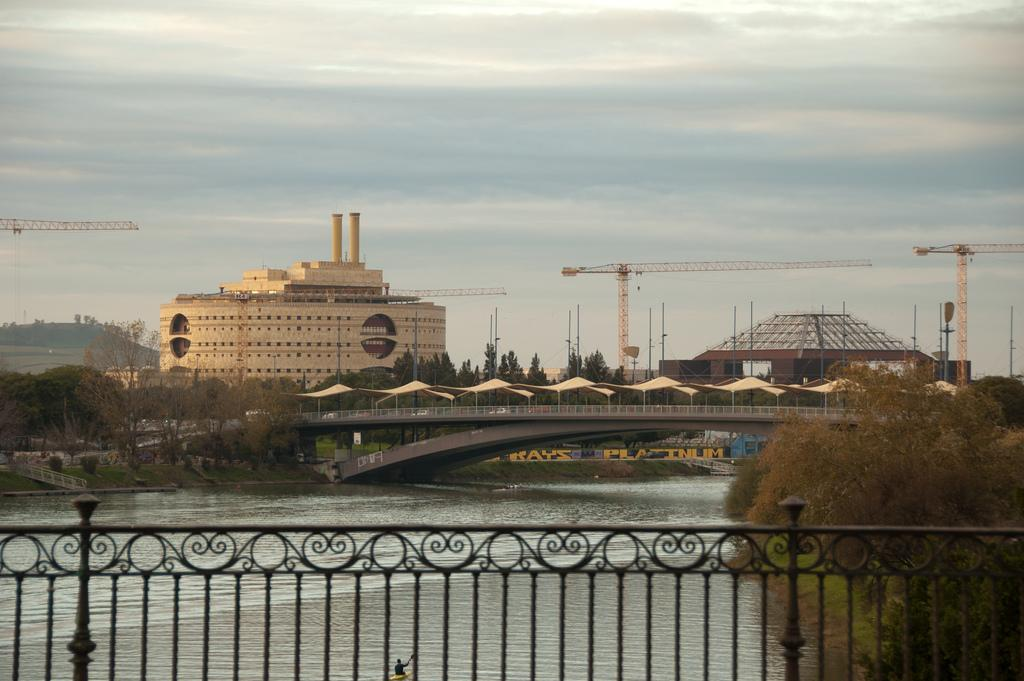What type of structure can be seen in the image? There is a bridge in the image. What is located behind the railing in the image? Water is visible behind the railing. What type of vegetation is present in the image? There are plants and trees visible in the image. What type of buildings can be seen in the image? There are buildings in the image. What is visible in the sky in the image? The sky is visible in the image, and clouds are present. What type of punishment is being administered to the person in the image? There is no person present in the image, and therefore no punishment can be observed. Can you tell me how fast the person is running in the image? There is no person present in the image, and therefore no running can be observed. 